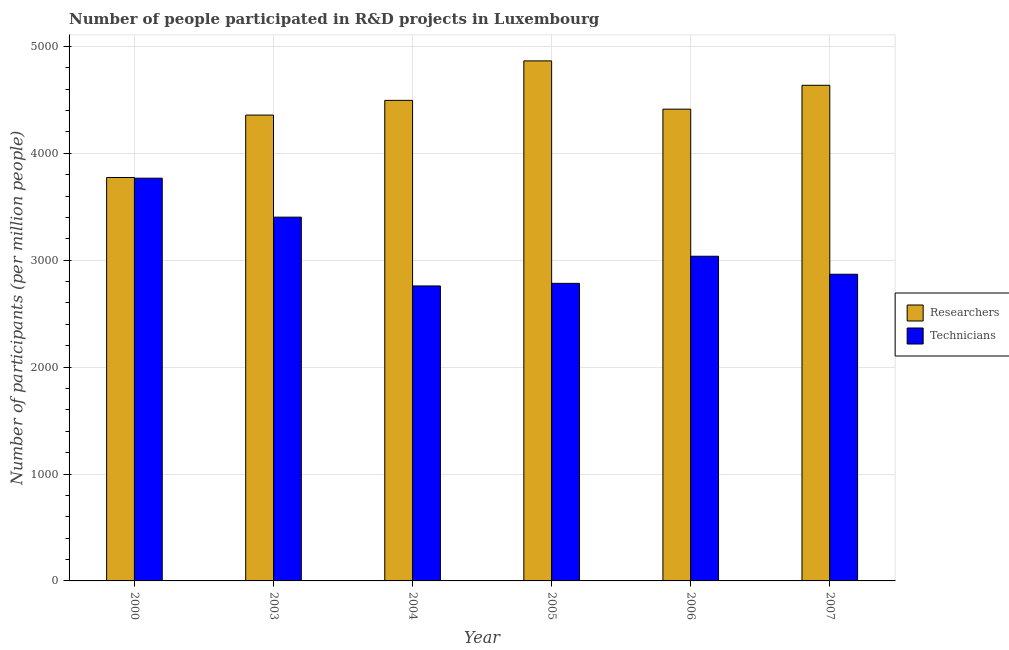How many groups of bars are there?
Your answer should be very brief. 6. Are the number of bars per tick equal to the number of legend labels?
Your answer should be very brief. Yes. Are the number of bars on each tick of the X-axis equal?
Your answer should be compact. Yes. How many bars are there on the 1st tick from the left?
Keep it short and to the point. 2. How many bars are there on the 5th tick from the right?
Provide a short and direct response. 2. What is the label of the 1st group of bars from the left?
Provide a short and direct response. 2000. In how many cases, is the number of bars for a given year not equal to the number of legend labels?
Offer a terse response. 0. What is the number of researchers in 2006?
Your response must be concise. 4412.45. Across all years, what is the maximum number of technicians?
Your answer should be compact. 3766.87. Across all years, what is the minimum number of researchers?
Make the answer very short. 3773.39. In which year was the number of researchers maximum?
Offer a very short reply. 2005. In which year was the number of technicians minimum?
Keep it short and to the point. 2004. What is the total number of researchers in the graph?
Keep it short and to the point. 2.65e+04. What is the difference between the number of technicians in 2000 and that in 2003?
Give a very brief answer. 364.42. What is the difference between the number of researchers in 2003 and the number of technicians in 2004?
Provide a succinct answer. -137.6. What is the average number of technicians per year?
Provide a short and direct response. 3102.75. In the year 2004, what is the difference between the number of researchers and number of technicians?
Make the answer very short. 0. What is the ratio of the number of researchers in 2000 to that in 2003?
Your answer should be very brief. 0.87. Is the difference between the number of technicians in 2000 and 2006 greater than the difference between the number of researchers in 2000 and 2006?
Offer a terse response. No. What is the difference between the highest and the second highest number of researchers?
Offer a terse response. 228.35. What is the difference between the highest and the lowest number of technicians?
Ensure brevity in your answer.  1007.96. Is the sum of the number of researchers in 2006 and 2007 greater than the maximum number of technicians across all years?
Give a very brief answer. Yes. What does the 1st bar from the left in 2003 represents?
Your response must be concise. Researchers. What does the 1st bar from the right in 2005 represents?
Provide a succinct answer. Technicians. How many bars are there?
Provide a short and direct response. 12. Are all the bars in the graph horizontal?
Your answer should be very brief. No. How many years are there in the graph?
Your answer should be very brief. 6. What is the difference between two consecutive major ticks on the Y-axis?
Provide a short and direct response. 1000. Does the graph contain grids?
Ensure brevity in your answer.  Yes. What is the title of the graph?
Keep it short and to the point. Number of people participated in R&D projects in Luxembourg. Does "Commercial service exports" appear as one of the legend labels in the graph?
Provide a short and direct response. No. What is the label or title of the Y-axis?
Ensure brevity in your answer.  Number of participants (per million people). What is the Number of participants (per million people) of Researchers in 2000?
Ensure brevity in your answer.  3773.39. What is the Number of participants (per million people) of Technicians in 2000?
Make the answer very short. 3766.87. What is the Number of participants (per million people) of Researchers in 2003?
Give a very brief answer. 4357.05. What is the Number of participants (per million people) in Technicians in 2003?
Offer a terse response. 3402.45. What is the Number of participants (per million people) of Researchers in 2004?
Keep it short and to the point. 4494.65. What is the Number of participants (per million people) of Technicians in 2004?
Your response must be concise. 2758.91. What is the Number of participants (per million people) of Researchers in 2005?
Provide a short and direct response. 4864.07. What is the Number of participants (per million people) in Technicians in 2005?
Keep it short and to the point. 2783.2. What is the Number of participants (per million people) of Researchers in 2006?
Give a very brief answer. 4412.45. What is the Number of participants (per million people) in Technicians in 2006?
Your response must be concise. 3036.82. What is the Number of participants (per million people) of Researchers in 2007?
Ensure brevity in your answer.  4635.72. What is the Number of participants (per million people) in Technicians in 2007?
Provide a succinct answer. 2868.27. Across all years, what is the maximum Number of participants (per million people) in Researchers?
Your response must be concise. 4864.07. Across all years, what is the maximum Number of participants (per million people) of Technicians?
Your answer should be very brief. 3766.87. Across all years, what is the minimum Number of participants (per million people) of Researchers?
Your response must be concise. 3773.39. Across all years, what is the minimum Number of participants (per million people) in Technicians?
Provide a succinct answer. 2758.91. What is the total Number of participants (per million people) in Researchers in the graph?
Your answer should be compact. 2.65e+04. What is the total Number of participants (per million people) of Technicians in the graph?
Your response must be concise. 1.86e+04. What is the difference between the Number of participants (per million people) of Researchers in 2000 and that in 2003?
Ensure brevity in your answer.  -583.66. What is the difference between the Number of participants (per million people) of Technicians in 2000 and that in 2003?
Offer a very short reply. 364.42. What is the difference between the Number of participants (per million people) of Researchers in 2000 and that in 2004?
Offer a terse response. -721.26. What is the difference between the Number of participants (per million people) in Technicians in 2000 and that in 2004?
Your response must be concise. 1007.96. What is the difference between the Number of participants (per million people) in Researchers in 2000 and that in 2005?
Your answer should be compact. -1090.68. What is the difference between the Number of participants (per million people) of Technicians in 2000 and that in 2005?
Your answer should be compact. 983.67. What is the difference between the Number of participants (per million people) of Researchers in 2000 and that in 2006?
Keep it short and to the point. -639.07. What is the difference between the Number of participants (per million people) in Technicians in 2000 and that in 2006?
Provide a succinct answer. 730.04. What is the difference between the Number of participants (per million people) of Researchers in 2000 and that in 2007?
Provide a short and direct response. -862.34. What is the difference between the Number of participants (per million people) of Technicians in 2000 and that in 2007?
Keep it short and to the point. 898.6. What is the difference between the Number of participants (per million people) in Researchers in 2003 and that in 2004?
Ensure brevity in your answer.  -137.6. What is the difference between the Number of participants (per million people) of Technicians in 2003 and that in 2004?
Give a very brief answer. 643.54. What is the difference between the Number of participants (per million people) of Researchers in 2003 and that in 2005?
Your response must be concise. -507.02. What is the difference between the Number of participants (per million people) of Technicians in 2003 and that in 2005?
Provide a short and direct response. 619.24. What is the difference between the Number of participants (per million people) of Researchers in 2003 and that in 2006?
Provide a short and direct response. -55.4. What is the difference between the Number of participants (per million people) in Technicians in 2003 and that in 2006?
Your answer should be very brief. 365.62. What is the difference between the Number of participants (per million people) of Researchers in 2003 and that in 2007?
Your answer should be compact. -278.67. What is the difference between the Number of participants (per million people) in Technicians in 2003 and that in 2007?
Keep it short and to the point. 534.17. What is the difference between the Number of participants (per million people) in Researchers in 2004 and that in 2005?
Ensure brevity in your answer.  -369.42. What is the difference between the Number of participants (per million people) of Technicians in 2004 and that in 2005?
Ensure brevity in your answer.  -24.29. What is the difference between the Number of participants (per million people) of Researchers in 2004 and that in 2006?
Provide a short and direct response. 82.2. What is the difference between the Number of participants (per million people) of Technicians in 2004 and that in 2006?
Provide a succinct answer. -277.91. What is the difference between the Number of participants (per million people) of Researchers in 2004 and that in 2007?
Offer a very short reply. -141.07. What is the difference between the Number of participants (per million people) of Technicians in 2004 and that in 2007?
Your answer should be very brief. -109.36. What is the difference between the Number of participants (per million people) of Researchers in 2005 and that in 2006?
Ensure brevity in your answer.  451.62. What is the difference between the Number of participants (per million people) in Technicians in 2005 and that in 2006?
Make the answer very short. -253.62. What is the difference between the Number of participants (per million people) in Researchers in 2005 and that in 2007?
Your answer should be compact. 228.35. What is the difference between the Number of participants (per million people) in Technicians in 2005 and that in 2007?
Your answer should be compact. -85.07. What is the difference between the Number of participants (per million people) of Researchers in 2006 and that in 2007?
Offer a very short reply. -223.27. What is the difference between the Number of participants (per million people) in Technicians in 2006 and that in 2007?
Offer a very short reply. 168.55. What is the difference between the Number of participants (per million people) in Researchers in 2000 and the Number of participants (per million people) in Technicians in 2003?
Make the answer very short. 370.94. What is the difference between the Number of participants (per million people) of Researchers in 2000 and the Number of participants (per million people) of Technicians in 2004?
Provide a short and direct response. 1014.47. What is the difference between the Number of participants (per million people) of Researchers in 2000 and the Number of participants (per million people) of Technicians in 2005?
Give a very brief answer. 990.18. What is the difference between the Number of participants (per million people) in Researchers in 2000 and the Number of participants (per million people) in Technicians in 2006?
Ensure brevity in your answer.  736.56. What is the difference between the Number of participants (per million people) of Researchers in 2000 and the Number of participants (per million people) of Technicians in 2007?
Offer a very short reply. 905.11. What is the difference between the Number of participants (per million people) in Researchers in 2003 and the Number of participants (per million people) in Technicians in 2004?
Ensure brevity in your answer.  1598.14. What is the difference between the Number of participants (per million people) of Researchers in 2003 and the Number of participants (per million people) of Technicians in 2005?
Provide a succinct answer. 1573.85. What is the difference between the Number of participants (per million people) of Researchers in 2003 and the Number of participants (per million people) of Technicians in 2006?
Ensure brevity in your answer.  1320.23. What is the difference between the Number of participants (per million people) of Researchers in 2003 and the Number of participants (per million people) of Technicians in 2007?
Provide a succinct answer. 1488.78. What is the difference between the Number of participants (per million people) of Researchers in 2004 and the Number of participants (per million people) of Technicians in 2005?
Ensure brevity in your answer.  1711.45. What is the difference between the Number of participants (per million people) of Researchers in 2004 and the Number of participants (per million people) of Technicians in 2006?
Offer a very short reply. 1457.83. What is the difference between the Number of participants (per million people) of Researchers in 2004 and the Number of participants (per million people) of Technicians in 2007?
Give a very brief answer. 1626.38. What is the difference between the Number of participants (per million people) in Researchers in 2005 and the Number of participants (per million people) in Technicians in 2006?
Give a very brief answer. 1827.25. What is the difference between the Number of participants (per million people) of Researchers in 2005 and the Number of participants (per million people) of Technicians in 2007?
Provide a succinct answer. 1995.8. What is the difference between the Number of participants (per million people) of Researchers in 2006 and the Number of participants (per million people) of Technicians in 2007?
Your response must be concise. 1544.18. What is the average Number of participants (per million people) in Researchers per year?
Your answer should be compact. 4422.89. What is the average Number of participants (per million people) of Technicians per year?
Provide a short and direct response. 3102.75. In the year 2000, what is the difference between the Number of participants (per million people) in Researchers and Number of participants (per million people) in Technicians?
Your response must be concise. 6.52. In the year 2003, what is the difference between the Number of participants (per million people) of Researchers and Number of participants (per million people) of Technicians?
Provide a succinct answer. 954.6. In the year 2004, what is the difference between the Number of participants (per million people) of Researchers and Number of participants (per million people) of Technicians?
Offer a very short reply. 1735.74. In the year 2005, what is the difference between the Number of participants (per million people) of Researchers and Number of participants (per million people) of Technicians?
Keep it short and to the point. 2080.87. In the year 2006, what is the difference between the Number of participants (per million people) of Researchers and Number of participants (per million people) of Technicians?
Offer a terse response. 1375.63. In the year 2007, what is the difference between the Number of participants (per million people) of Researchers and Number of participants (per million people) of Technicians?
Provide a short and direct response. 1767.45. What is the ratio of the Number of participants (per million people) in Researchers in 2000 to that in 2003?
Keep it short and to the point. 0.87. What is the ratio of the Number of participants (per million people) in Technicians in 2000 to that in 2003?
Ensure brevity in your answer.  1.11. What is the ratio of the Number of participants (per million people) of Researchers in 2000 to that in 2004?
Offer a very short reply. 0.84. What is the ratio of the Number of participants (per million people) of Technicians in 2000 to that in 2004?
Provide a succinct answer. 1.37. What is the ratio of the Number of participants (per million people) of Researchers in 2000 to that in 2005?
Give a very brief answer. 0.78. What is the ratio of the Number of participants (per million people) in Technicians in 2000 to that in 2005?
Make the answer very short. 1.35. What is the ratio of the Number of participants (per million people) of Researchers in 2000 to that in 2006?
Offer a very short reply. 0.86. What is the ratio of the Number of participants (per million people) of Technicians in 2000 to that in 2006?
Your answer should be very brief. 1.24. What is the ratio of the Number of participants (per million people) in Researchers in 2000 to that in 2007?
Your answer should be compact. 0.81. What is the ratio of the Number of participants (per million people) in Technicians in 2000 to that in 2007?
Make the answer very short. 1.31. What is the ratio of the Number of participants (per million people) of Researchers in 2003 to that in 2004?
Ensure brevity in your answer.  0.97. What is the ratio of the Number of participants (per million people) of Technicians in 2003 to that in 2004?
Keep it short and to the point. 1.23. What is the ratio of the Number of participants (per million people) of Researchers in 2003 to that in 2005?
Your answer should be very brief. 0.9. What is the ratio of the Number of participants (per million people) in Technicians in 2003 to that in 2005?
Provide a short and direct response. 1.22. What is the ratio of the Number of participants (per million people) in Researchers in 2003 to that in 2006?
Provide a succinct answer. 0.99. What is the ratio of the Number of participants (per million people) in Technicians in 2003 to that in 2006?
Give a very brief answer. 1.12. What is the ratio of the Number of participants (per million people) in Researchers in 2003 to that in 2007?
Provide a short and direct response. 0.94. What is the ratio of the Number of participants (per million people) of Technicians in 2003 to that in 2007?
Your response must be concise. 1.19. What is the ratio of the Number of participants (per million people) in Researchers in 2004 to that in 2005?
Offer a terse response. 0.92. What is the ratio of the Number of participants (per million people) in Researchers in 2004 to that in 2006?
Provide a short and direct response. 1.02. What is the ratio of the Number of participants (per million people) in Technicians in 2004 to that in 2006?
Your response must be concise. 0.91. What is the ratio of the Number of participants (per million people) of Researchers in 2004 to that in 2007?
Your answer should be very brief. 0.97. What is the ratio of the Number of participants (per million people) of Technicians in 2004 to that in 2007?
Provide a short and direct response. 0.96. What is the ratio of the Number of participants (per million people) in Researchers in 2005 to that in 2006?
Provide a succinct answer. 1.1. What is the ratio of the Number of participants (per million people) of Technicians in 2005 to that in 2006?
Your answer should be compact. 0.92. What is the ratio of the Number of participants (per million people) of Researchers in 2005 to that in 2007?
Offer a very short reply. 1.05. What is the ratio of the Number of participants (per million people) in Technicians in 2005 to that in 2007?
Make the answer very short. 0.97. What is the ratio of the Number of participants (per million people) of Researchers in 2006 to that in 2007?
Provide a short and direct response. 0.95. What is the ratio of the Number of participants (per million people) in Technicians in 2006 to that in 2007?
Ensure brevity in your answer.  1.06. What is the difference between the highest and the second highest Number of participants (per million people) of Researchers?
Your answer should be compact. 228.35. What is the difference between the highest and the second highest Number of participants (per million people) in Technicians?
Give a very brief answer. 364.42. What is the difference between the highest and the lowest Number of participants (per million people) of Researchers?
Your answer should be compact. 1090.68. What is the difference between the highest and the lowest Number of participants (per million people) in Technicians?
Make the answer very short. 1007.96. 